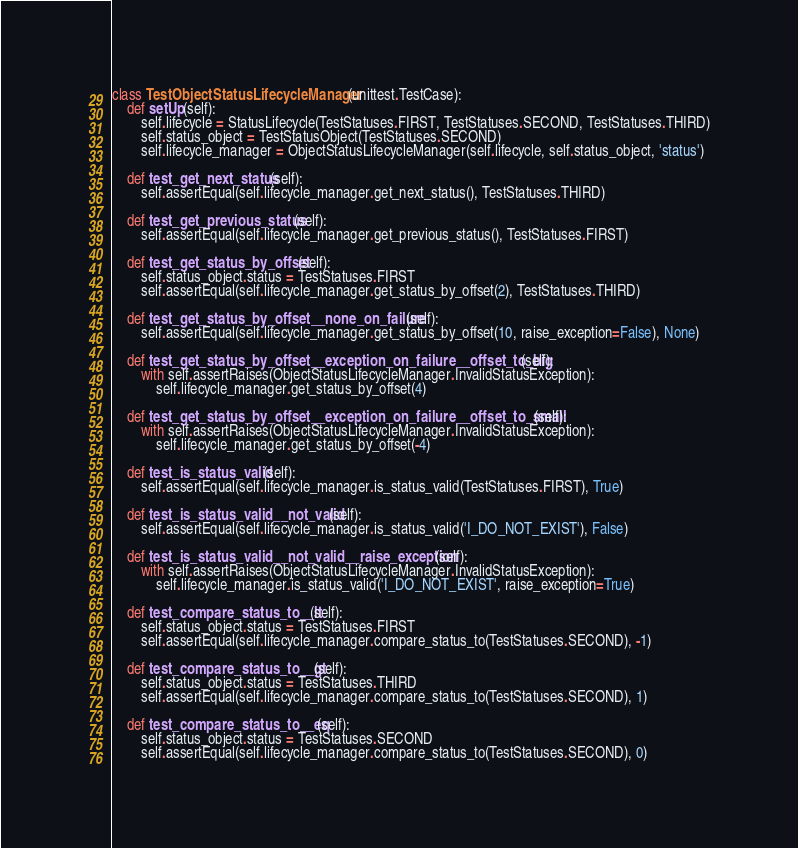Convert code to text. <code><loc_0><loc_0><loc_500><loc_500><_Python_>

class TestObjectStatusLifecycleManager(unittest.TestCase):
    def setUp(self):
        self.lifecycle = StatusLifecycle(TestStatuses.FIRST, TestStatuses.SECOND, TestStatuses.THIRD)
        self.status_object = TestStatusObject(TestStatuses.SECOND)
        self.lifecycle_manager = ObjectStatusLifecycleManager(self.lifecycle, self.status_object, 'status')

    def test_get_next_status(self):
        self.assertEqual(self.lifecycle_manager.get_next_status(), TestStatuses.THIRD)

    def test_get_previous_status(self):
        self.assertEqual(self.lifecycle_manager.get_previous_status(), TestStatuses.FIRST)

    def test_get_status_by_offset(self):
        self.status_object.status = TestStatuses.FIRST
        self.assertEqual(self.lifecycle_manager.get_status_by_offset(2), TestStatuses.THIRD)

    def test_get_status_by_offset__none_on_failure(self):
        self.assertEqual(self.lifecycle_manager.get_status_by_offset(10, raise_exception=False), None)

    def test_get_status_by_offset__exception_on_failure__offset_to_big(self):
        with self.assertRaises(ObjectStatusLifecycleManager.InvalidStatusException):
            self.lifecycle_manager.get_status_by_offset(4)

    def test_get_status_by_offset__exception_on_failure__offset_to_small(self):
        with self.assertRaises(ObjectStatusLifecycleManager.InvalidStatusException):
            self.lifecycle_manager.get_status_by_offset(-4)

    def test_is_status_valid(self):
        self.assertEqual(self.lifecycle_manager.is_status_valid(TestStatuses.FIRST), True)

    def test_is_status_valid__not_valid(self):
        self.assertEqual(self.lifecycle_manager.is_status_valid('I_DO_NOT_EXIST'), False)

    def test_is_status_valid__not_valid__raise_exception(self):
        with self.assertRaises(ObjectStatusLifecycleManager.InvalidStatusException):
            self.lifecycle_manager.is_status_valid('I_DO_NOT_EXIST', raise_exception=True)

    def test_compare_status_to__lt(self):
        self.status_object.status = TestStatuses.FIRST
        self.assertEqual(self.lifecycle_manager.compare_status_to(TestStatuses.SECOND), -1)

    def test_compare_status_to__gt(self):
        self.status_object.status = TestStatuses.THIRD
        self.assertEqual(self.lifecycle_manager.compare_status_to(TestStatuses.SECOND), 1)

    def test_compare_status_to__eq(self):
        self.status_object.status = TestStatuses.SECOND
        self.assertEqual(self.lifecycle_manager.compare_status_to(TestStatuses.SECOND), 0)
</code> 